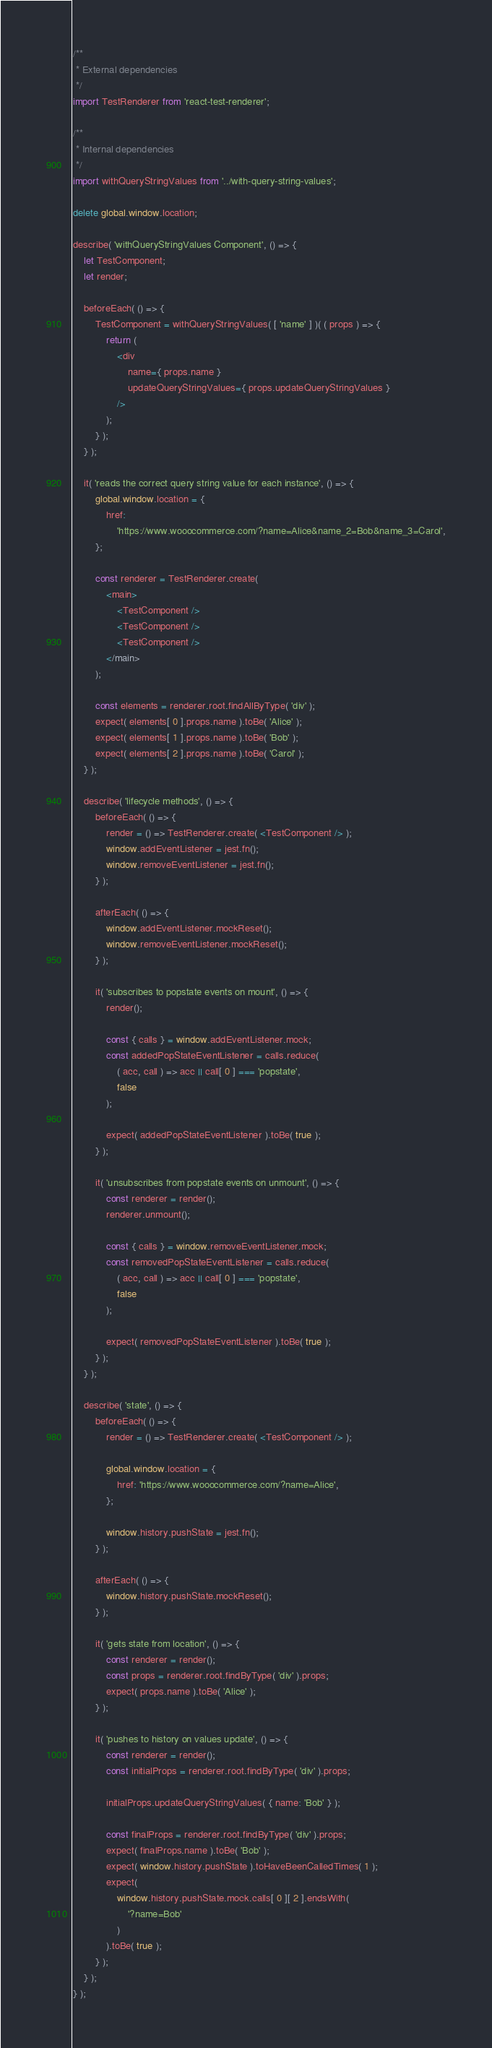<code> <loc_0><loc_0><loc_500><loc_500><_JavaScript_>/**
 * External dependencies
 */
import TestRenderer from 'react-test-renderer';

/**
 * Internal dependencies
 */
import withQueryStringValues from '../with-query-string-values';

delete global.window.location;

describe( 'withQueryStringValues Component', () => {
	let TestComponent;
	let render;

	beforeEach( () => {
		TestComponent = withQueryStringValues( [ 'name' ] )( ( props ) => {
			return (
				<div
					name={ props.name }
					updateQueryStringValues={ props.updateQueryStringValues }
				/>
			);
		} );
	} );

	it( 'reads the correct query string value for each instance', () => {
		global.window.location = {
			href:
				'https://www.wooocommerce.com/?name=Alice&name_2=Bob&name_3=Carol',
		};

		const renderer = TestRenderer.create(
			<main>
				<TestComponent />
				<TestComponent />
				<TestComponent />
			</main>
		);

		const elements = renderer.root.findAllByType( 'div' );
		expect( elements[ 0 ].props.name ).toBe( 'Alice' );
		expect( elements[ 1 ].props.name ).toBe( 'Bob' );
		expect( elements[ 2 ].props.name ).toBe( 'Carol' );
	} );

	describe( 'lifecycle methods', () => {
		beforeEach( () => {
			render = () => TestRenderer.create( <TestComponent /> );
			window.addEventListener = jest.fn();
			window.removeEventListener = jest.fn();
		} );

		afterEach( () => {
			window.addEventListener.mockReset();
			window.removeEventListener.mockReset();
		} );

		it( 'subscribes to popstate events on mount', () => {
			render();

			const { calls } = window.addEventListener.mock;
			const addedPopStateEventListener = calls.reduce(
				( acc, call ) => acc || call[ 0 ] === 'popstate',
				false
			);

			expect( addedPopStateEventListener ).toBe( true );
		} );

		it( 'unsubscribes from popstate events on unmount', () => {
			const renderer = render();
			renderer.unmount();

			const { calls } = window.removeEventListener.mock;
			const removedPopStateEventListener = calls.reduce(
				( acc, call ) => acc || call[ 0 ] === 'popstate',
				false
			);

			expect( removedPopStateEventListener ).toBe( true );
		} );
	} );

	describe( 'state', () => {
		beforeEach( () => {
			render = () => TestRenderer.create( <TestComponent /> );

			global.window.location = {
				href: 'https://www.wooocommerce.com/?name=Alice',
			};

			window.history.pushState = jest.fn();
		} );

		afterEach( () => {
			window.history.pushState.mockReset();
		} );

		it( 'gets state from location', () => {
			const renderer = render();
			const props = renderer.root.findByType( 'div' ).props;
			expect( props.name ).toBe( 'Alice' );
		} );

		it( 'pushes to history on values update', () => {
			const renderer = render();
			const initialProps = renderer.root.findByType( 'div' ).props;

			initialProps.updateQueryStringValues( { name: 'Bob' } );

			const finalProps = renderer.root.findByType( 'div' ).props;
			expect( finalProps.name ).toBe( 'Bob' );
			expect( window.history.pushState ).toHaveBeenCalledTimes( 1 );
			expect(
				window.history.pushState.mock.calls[ 0 ][ 2 ].endsWith(
					'?name=Bob'
				)
			).toBe( true );
		} );
	} );
} );
</code> 